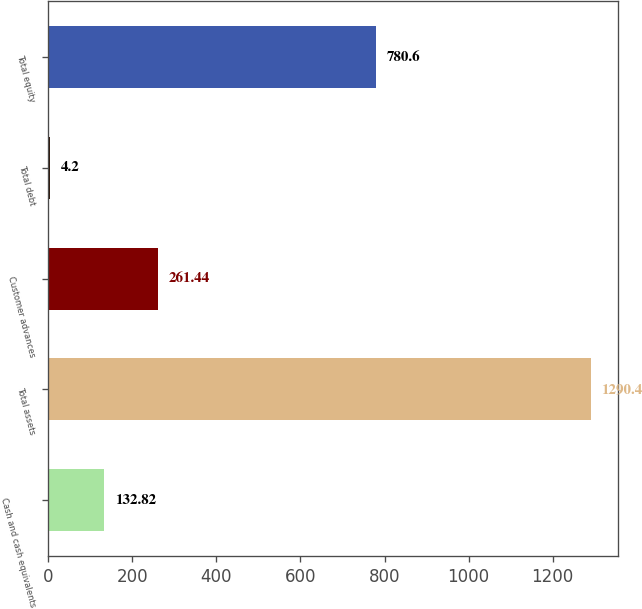Convert chart to OTSL. <chart><loc_0><loc_0><loc_500><loc_500><bar_chart><fcel>Cash and cash equivalents<fcel>Total assets<fcel>Customer advances<fcel>Total debt<fcel>Total equity<nl><fcel>132.82<fcel>1290.4<fcel>261.44<fcel>4.2<fcel>780.6<nl></chart> 